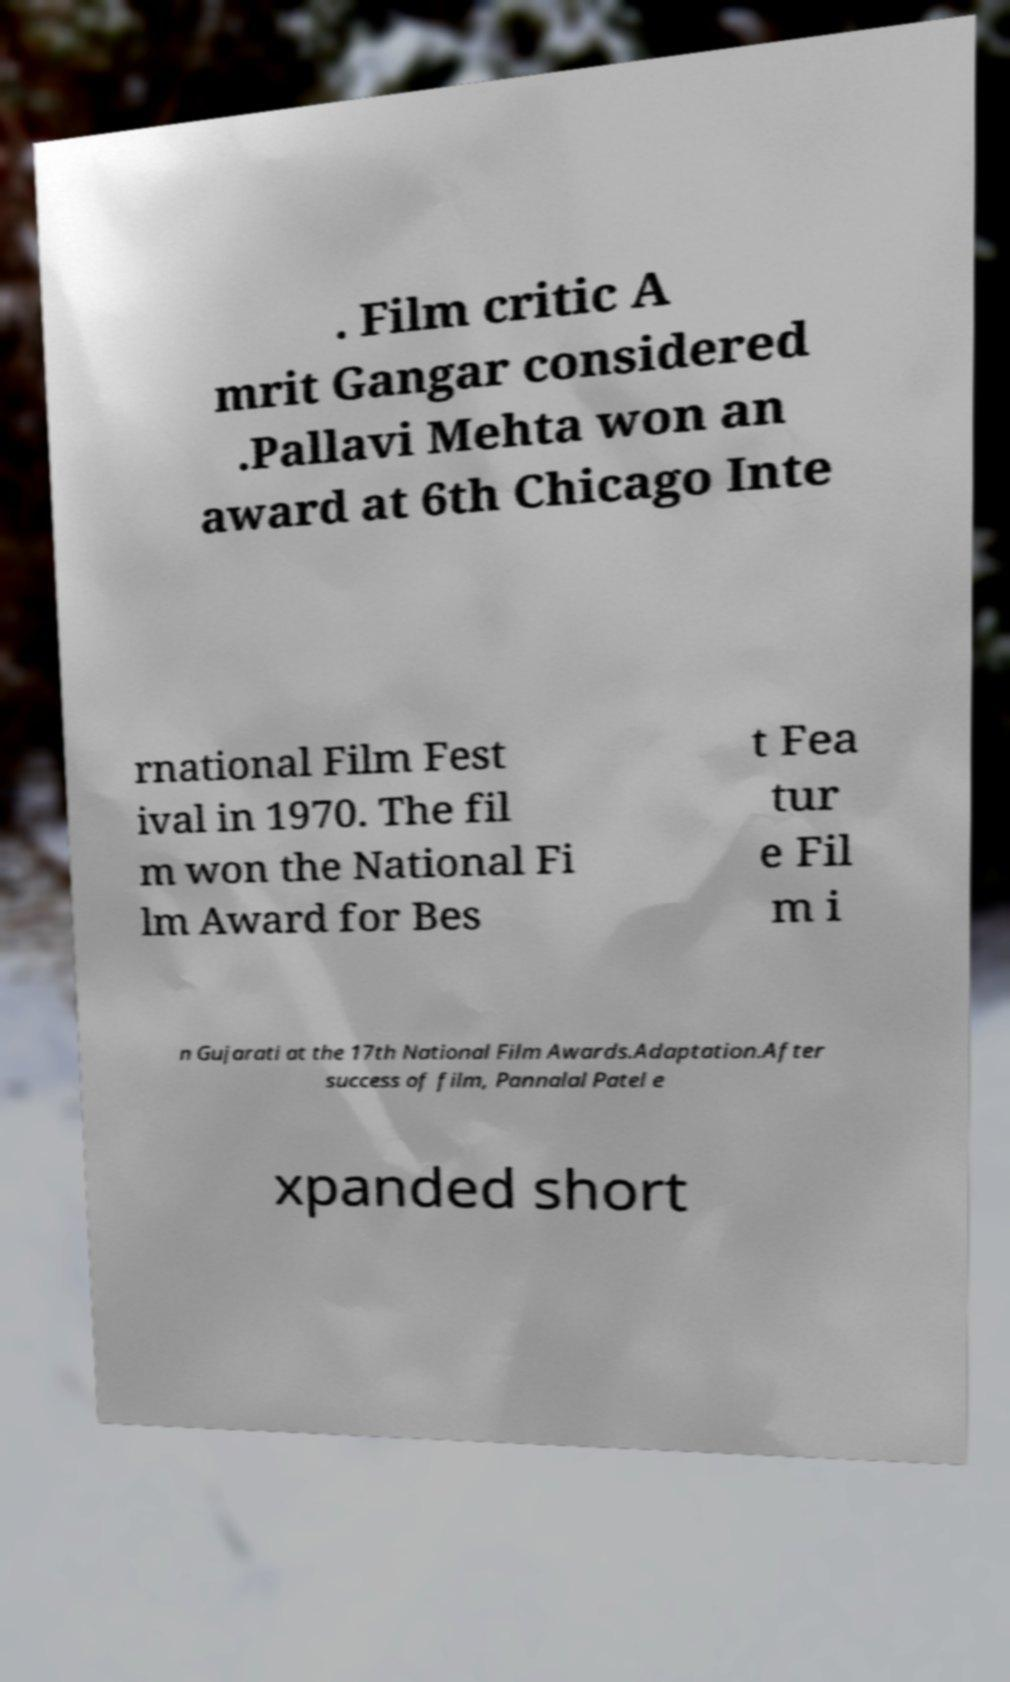For documentation purposes, I need the text within this image transcribed. Could you provide that? . Film critic A mrit Gangar considered .Pallavi Mehta won an award at 6th Chicago Inte rnational Film Fest ival in 1970. The fil m won the National Fi lm Award for Bes t Fea tur e Fil m i n Gujarati at the 17th National Film Awards.Adaptation.After success of film, Pannalal Patel e xpanded short 